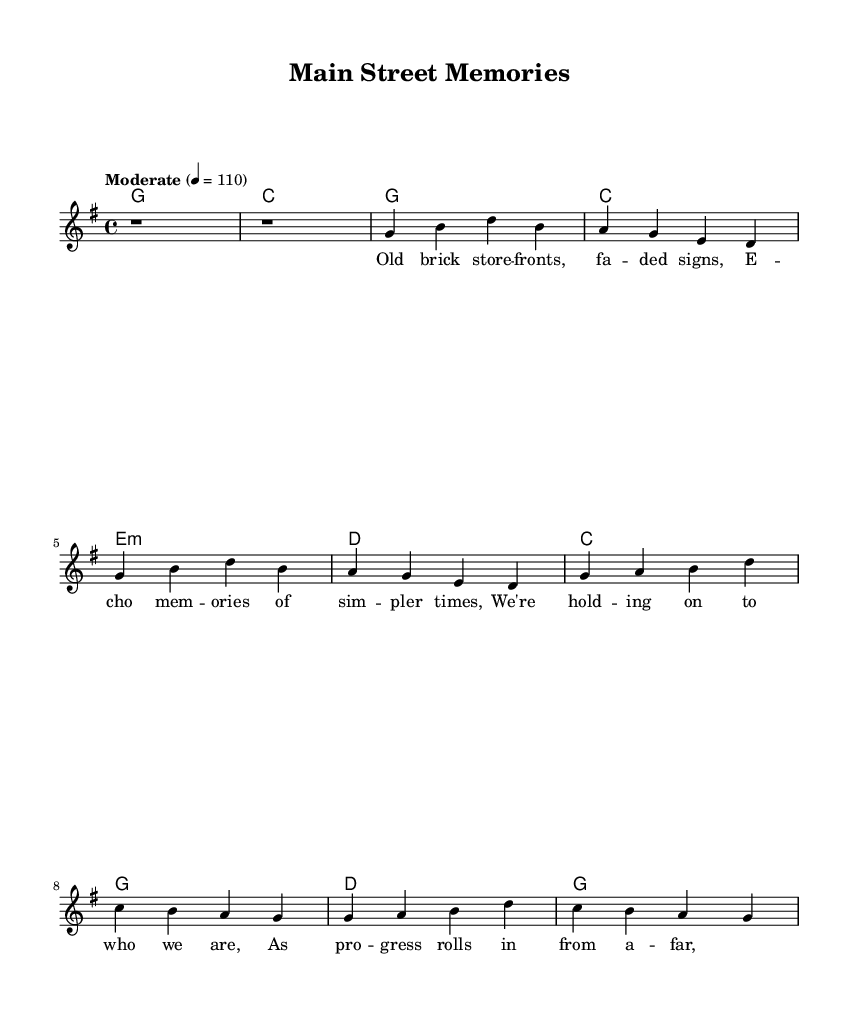What is the key signature of this music? The key signature shows two sharps, indicating it is in G major, which consists of the notes G, A, B, C, D, E, and F#.
Answer: G major What is the time signature of the music? The time signature is shown at the beginning of the sheet music as 4/4, meaning there are four beats in each measure, and the quarter note gets one beat.
Answer: 4/4 What is the tempo marking for this piece? The tempo is specified as "Moderate" with a metronome marking of quarter note equals 110 beats per minute, indicating how fast the music should be played.
Answer: Moderate 4 = 110 What is the first chord played in the piece? The chords are indicated at the beginning, and the first chord is G major, written as a whole note in the harmonies.
Answer: G How many times is the chorus repeated? The chorus is represented in the sheet music as containing two sections, each repeated once in the text, indicating that the chorus is played twice.
Answer: 2 Which lyrical themes are conveyed in the verse? The verse lyrics mention "old brick store fronts" and "echo memories of simpler times," reflecting nostalgia and the impact of change in small-town identity.
Answer: Nostalgia What does the phrase "as progress rolls in from afar" suggest about the community's perspective? This phrase illustrates a tension between maintaining traditional community values and the inevitable changes brought by modernization and external influences.
Answer: Tension 